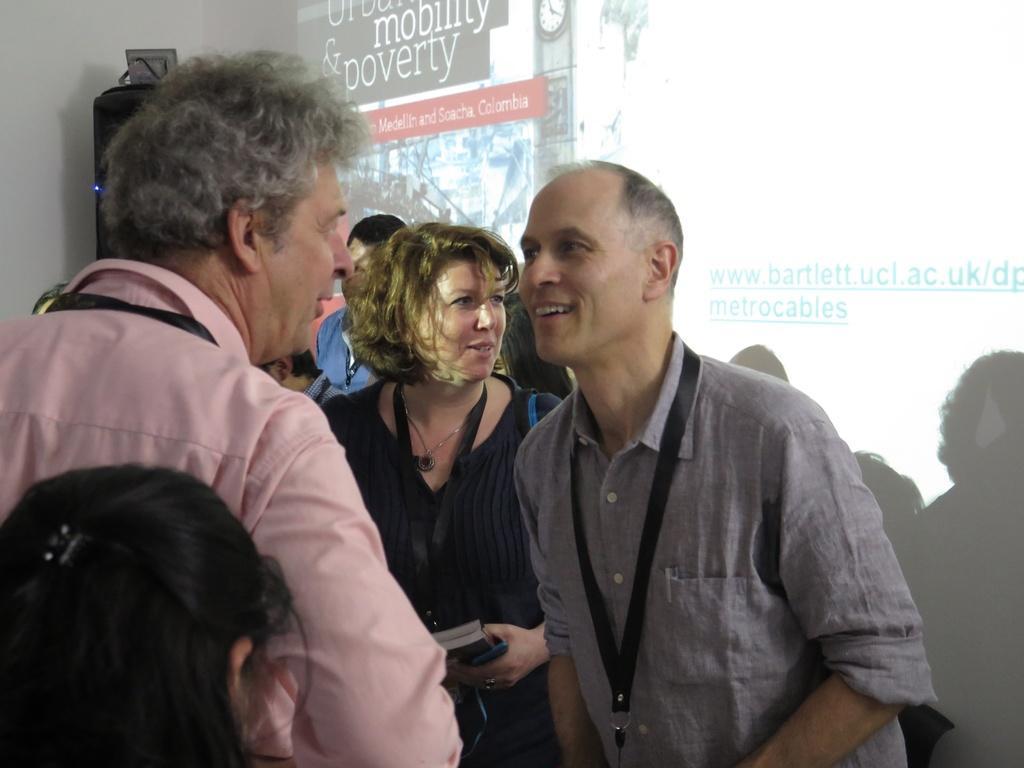Describe this image in one or two sentences. In this image, I can see a group of people standing. In the background, there is a screen and an object. 